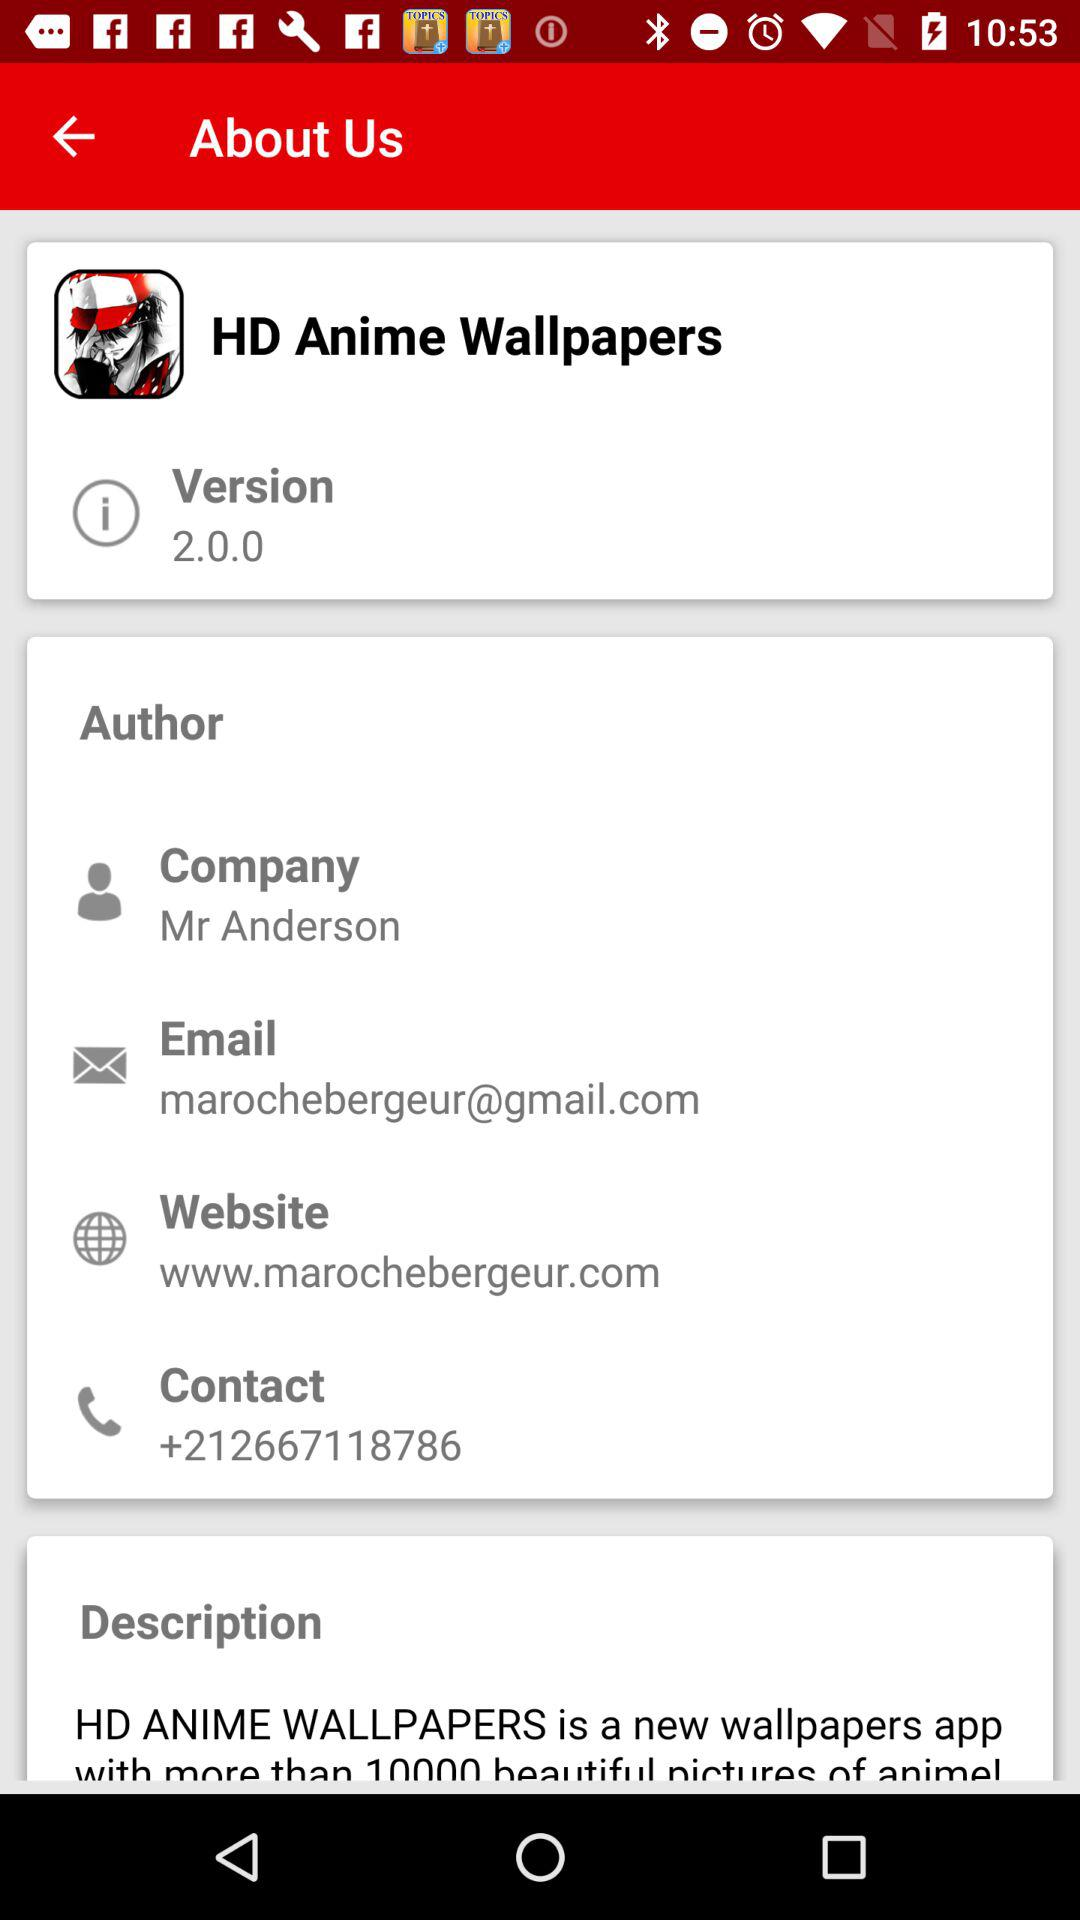What is the application name? The application name is "HD Anime Wallpapers". 